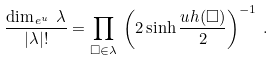<formula> <loc_0><loc_0><loc_500><loc_500>\frac { \dim _ { \, e ^ { u } } \, \lambda } { | \lambda | ! } = \prod _ { \square \in \lambda } \, \left ( 2 \sinh \frac { u h ( \square ) } 2 \right ) ^ { - 1 } \, .</formula> 